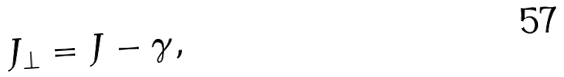Convert formula to latex. <formula><loc_0><loc_0><loc_500><loc_500>J _ { \perp } = J - \gamma ,</formula> 